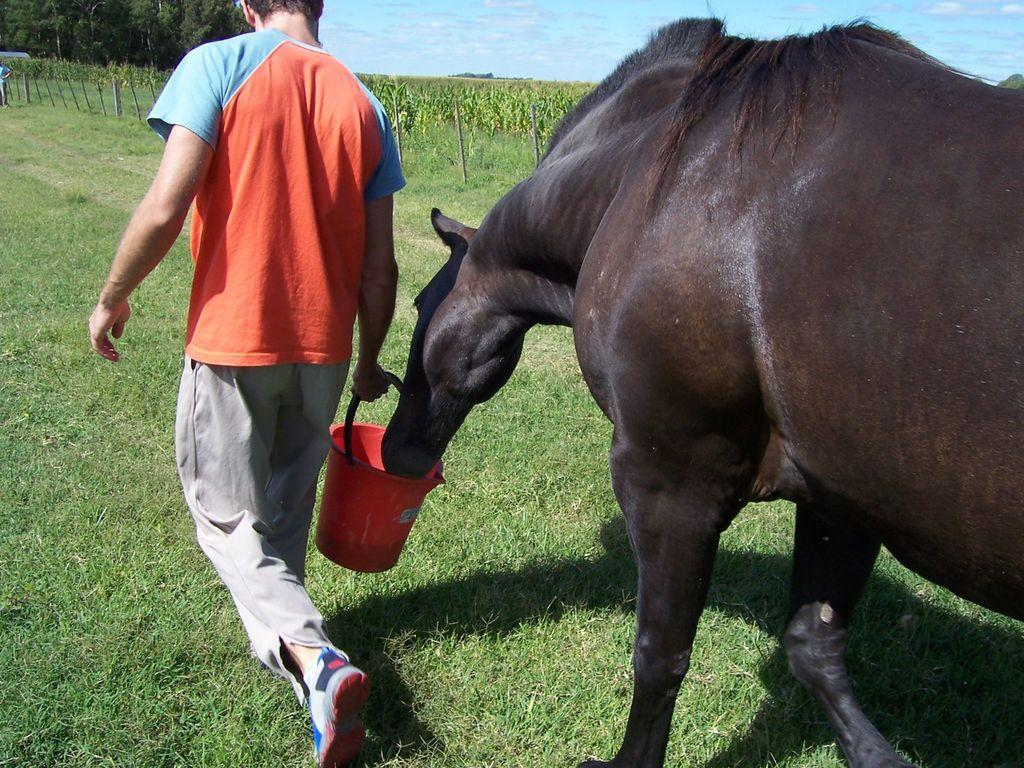What is the man in the image holding? The man is holding a bucket in the image. What can be seen on the right side of the image? There is an animal on the right side of the image. What type of vegetation is visible in the image? Trees and grass are present in the image. What is visible at the top of the image? The sky is visible at the top of the image. What type of sea creature is visible in the image? There is no sea creature present in the image; it features a man holding a bucket, an animal, trees, grass, and the sky. What verse is being recited by the animal in the image? There is no indication that the animal is reciting a verse in the image. 